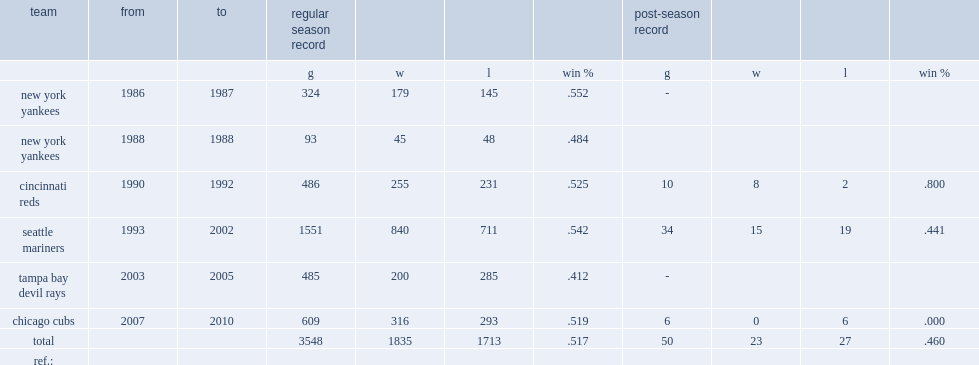Write the full table. {'header': ['team', 'from', 'to', 'regular season record', '', '', '', 'post-season record', '', '', ''], 'rows': [['', '', '', 'g', 'w', 'l', 'win %', 'g', 'w', 'l', 'win %'], ['new york yankees', '1986', '1987', '324', '179', '145', '.552', '-', '', '', ''], ['new york yankees', '1988', '1988', '93', '45', '48', '.484', '', '', '', ''], ['cincinnati reds', '1990', '1992', '486', '255', '231', '.525', '10', '8', '2', '.800'], ['seattle mariners', '1993', '2002', '1551', '840', '711', '.542', '34', '15', '19', '.441'], ['tampa bay devil rays', '2003', '2005', '485', '200', '285', '.412', '-', '', '', ''], ['chicago cubs', '2007', '2010', '609', '316', '293', '.519', '6', '0', '6', '.000'], ['total', '', '', '3548', '1835', '1713', '.517', '50', '23', '27', '.460'], ['ref.:', '', '', '', '', '', '', '', '', '', '']]} What was the result of wins and losses in seattle mariners? 840.0 711.0. 